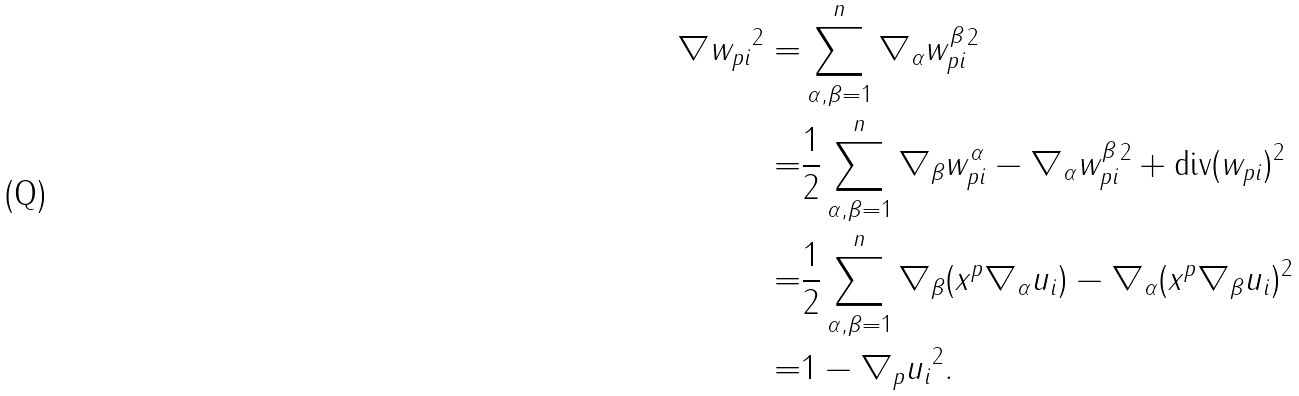<formula> <loc_0><loc_0><loc_500><loc_500>\| \nabla { w } _ { p i } \| ^ { 2 } = & \sum _ { \alpha , \beta = 1 } ^ { n } \| \nabla _ { \alpha } w _ { p i } ^ { \beta } \| ^ { 2 } \\ = & \frac { 1 } { 2 } \sum _ { \alpha , \beta = 1 } ^ { n } \| \nabla _ { \beta } w _ { p i } ^ { \alpha } - \nabla _ { \alpha } w _ { p i } ^ { \beta } \| ^ { 2 } + \| { \text {div} } ( { w } _ { p i } ) \| ^ { 2 } \quad \\ = & \frac { 1 } { 2 } \sum _ { \alpha , \beta = 1 } ^ { n } \| \nabla _ { \beta } ( x ^ { p } \nabla _ { \alpha } u _ { i } ) - \nabla _ { \alpha } ( x ^ { p } \nabla _ { \beta } u _ { i } ) \| ^ { 2 } \\ = & 1 - \| \nabla _ { p } u _ { i } \| ^ { 2 } .</formula> 